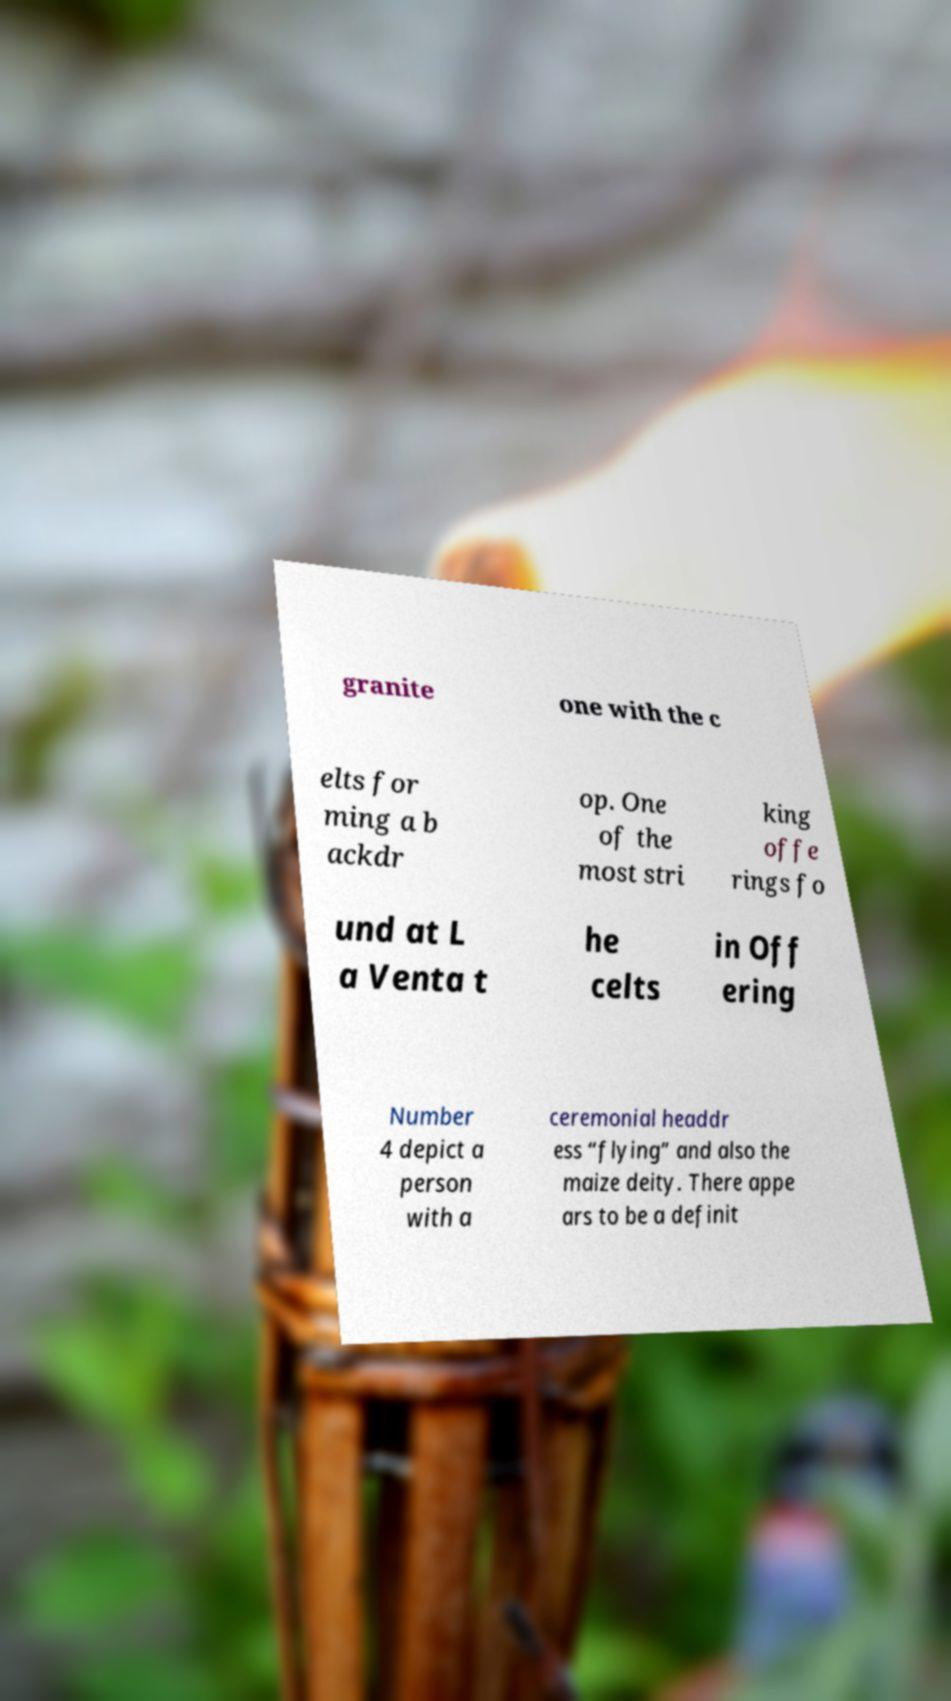Can you accurately transcribe the text from the provided image for me? granite one with the c elts for ming a b ackdr op. One of the most stri king offe rings fo und at L a Venta t he celts in Off ering Number 4 depict a person with a ceremonial headdr ess “flying” and also the maize deity. There appe ars to be a definit 